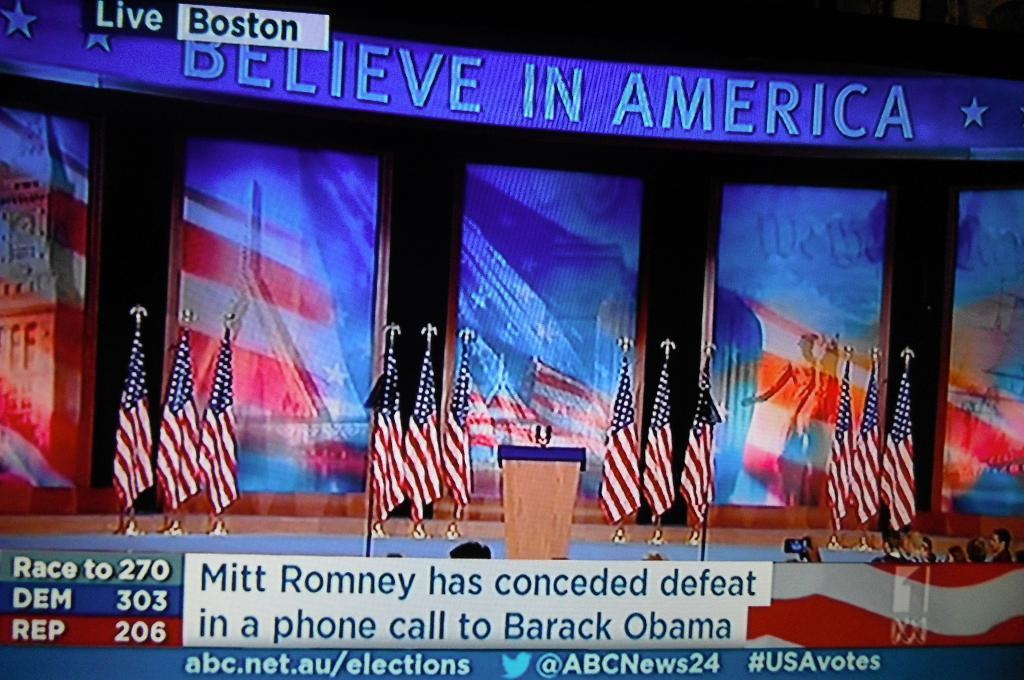What is the main object in the image? There is a screen in the image. What is shown on the screen? The screen displays many flags. Where is the screen located? The screen is on a stage. What is in the center of the stage? There is a dias in the middle of the stage. What is happening at the bottom of the screen? There are scrolling texts or images at the bottom of the screen. How many bells can be heard ringing in the image? There are no bells present in the image, and therefore no sound can be heard. What type of books are being read by the rat in the image? There is no rat or books present in the image. 